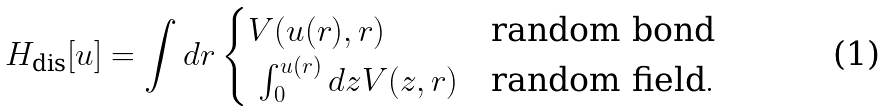Convert formula to latex. <formula><loc_0><loc_0><loc_500><loc_500>H _ { \text {dis} } [ u ] = \int d r \begin{cases} V ( u ( r ) , r ) & \text {random bond} \\ \ \int _ { 0 } ^ { u ( r ) } d z V ( z , r ) & \text {random field} . \end{cases}</formula> 